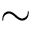Convert formula to latex. <formula><loc_0><loc_0><loc_500><loc_500>\sim</formula> 